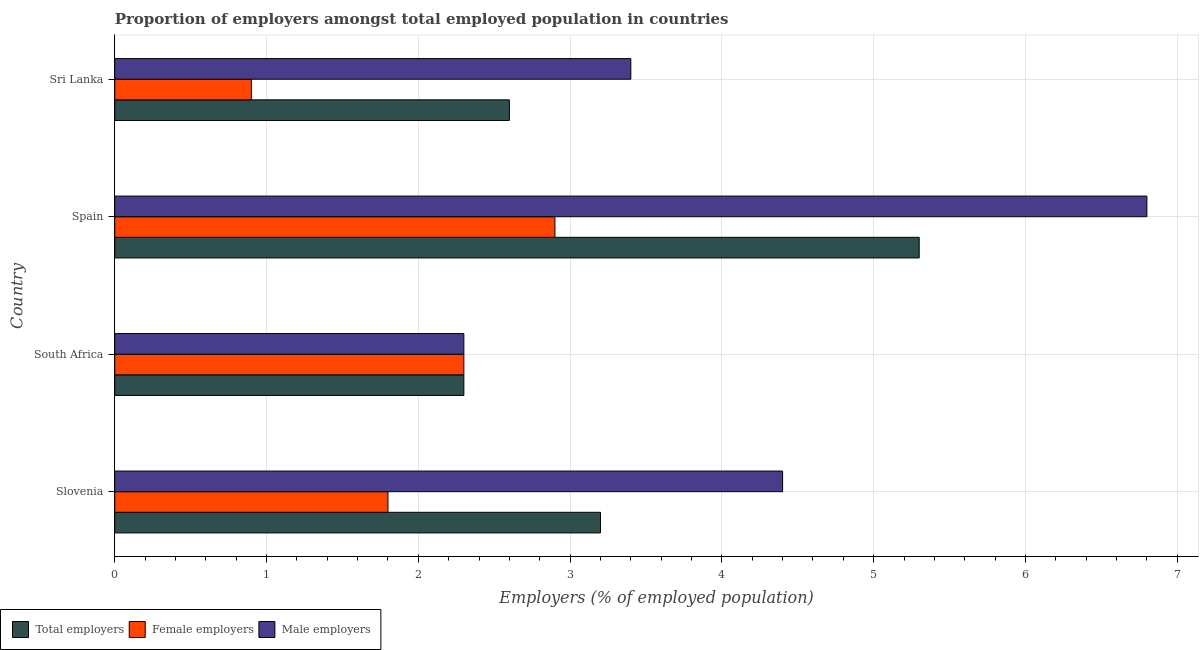How many different coloured bars are there?
Offer a very short reply. 3. Are the number of bars per tick equal to the number of legend labels?
Make the answer very short. Yes. How many bars are there on the 3rd tick from the top?
Your answer should be compact. 3. How many bars are there on the 3rd tick from the bottom?
Your response must be concise. 3. What is the label of the 4th group of bars from the top?
Make the answer very short. Slovenia. In how many cases, is the number of bars for a given country not equal to the number of legend labels?
Give a very brief answer. 0. What is the percentage of total employers in Spain?
Give a very brief answer. 5.3. Across all countries, what is the maximum percentage of male employers?
Your answer should be very brief. 6.8. Across all countries, what is the minimum percentage of male employers?
Offer a very short reply. 2.3. In which country was the percentage of male employers maximum?
Give a very brief answer. Spain. In which country was the percentage of total employers minimum?
Ensure brevity in your answer.  South Africa. What is the total percentage of female employers in the graph?
Your answer should be very brief. 7.9. What is the difference between the percentage of male employers in South Africa and the percentage of female employers in Slovenia?
Your answer should be very brief. 0.5. What is the average percentage of female employers per country?
Offer a very short reply. 1.98. What is the difference between the percentage of male employers and percentage of total employers in Sri Lanka?
Provide a succinct answer. 0.8. What is the ratio of the percentage of male employers in Slovenia to that in South Africa?
Your answer should be compact. 1.91. Is the difference between the percentage of total employers in South Africa and Spain greater than the difference between the percentage of female employers in South Africa and Spain?
Keep it short and to the point. No. What does the 2nd bar from the top in South Africa represents?
Provide a succinct answer. Female employers. What does the 1st bar from the bottom in South Africa represents?
Offer a terse response. Total employers. Are all the bars in the graph horizontal?
Offer a very short reply. Yes. Are the values on the major ticks of X-axis written in scientific E-notation?
Your answer should be compact. No. Does the graph contain any zero values?
Give a very brief answer. No. How many legend labels are there?
Your answer should be very brief. 3. What is the title of the graph?
Provide a succinct answer. Proportion of employers amongst total employed population in countries. Does "Taxes" appear as one of the legend labels in the graph?
Your response must be concise. No. What is the label or title of the X-axis?
Your answer should be compact. Employers (% of employed population). What is the label or title of the Y-axis?
Your answer should be very brief. Country. What is the Employers (% of employed population) in Total employers in Slovenia?
Offer a very short reply. 3.2. What is the Employers (% of employed population) in Female employers in Slovenia?
Offer a very short reply. 1.8. What is the Employers (% of employed population) in Male employers in Slovenia?
Offer a terse response. 4.4. What is the Employers (% of employed population) in Total employers in South Africa?
Your response must be concise. 2.3. What is the Employers (% of employed population) in Female employers in South Africa?
Ensure brevity in your answer.  2.3. What is the Employers (% of employed population) of Male employers in South Africa?
Your answer should be compact. 2.3. What is the Employers (% of employed population) in Total employers in Spain?
Provide a short and direct response. 5.3. What is the Employers (% of employed population) of Female employers in Spain?
Provide a short and direct response. 2.9. What is the Employers (% of employed population) of Male employers in Spain?
Ensure brevity in your answer.  6.8. What is the Employers (% of employed population) of Total employers in Sri Lanka?
Offer a terse response. 2.6. What is the Employers (% of employed population) in Female employers in Sri Lanka?
Give a very brief answer. 0.9. What is the Employers (% of employed population) in Male employers in Sri Lanka?
Offer a terse response. 3.4. Across all countries, what is the maximum Employers (% of employed population) in Total employers?
Offer a very short reply. 5.3. Across all countries, what is the maximum Employers (% of employed population) of Female employers?
Make the answer very short. 2.9. Across all countries, what is the maximum Employers (% of employed population) in Male employers?
Ensure brevity in your answer.  6.8. Across all countries, what is the minimum Employers (% of employed population) in Total employers?
Your answer should be compact. 2.3. Across all countries, what is the minimum Employers (% of employed population) in Female employers?
Make the answer very short. 0.9. Across all countries, what is the minimum Employers (% of employed population) in Male employers?
Offer a very short reply. 2.3. What is the total Employers (% of employed population) of Total employers in the graph?
Make the answer very short. 13.4. What is the difference between the Employers (% of employed population) in Total employers in Slovenia and that in South Africa?
Offer a very short reply. 0.9. What is the difference between the Employers (% of employed population) in Female employers in Slovenia and that in South Africa?
Keep it short and to the point. -0.5. What is the difference between the Employers (% of employed population) of Male employers in Slovenia and that in South Africa?
Make the answer very short. 2.1. What is the difference between the Employers (% of employed population) of Male employers in Slovenia and that in Spain?
Your answer should be very brief. -2.4. What is the difference between the Employers (% of employed population) of Total employers in Slovenia and that in Sri Lanka?
Give a very brief answer. 0.6. What is the difference between the Employers (% of employed population) in Female employers in Slovenia and that in Sri Lanka?
Keep it short and to the point. 0.9. What is the difference between the Employers (% of employed population) of Male employers in Slovenia and that in Sri Lanka?
Provide a succinct answer. 1. What is the difference between the Employers (% of employed population) of Total employers in South Africa and that in Spain?
Ensure brevity in your answer.  -3. What is the difference between the Employers (% of employed population) of Female employers in South Africa and that in Spain?
Give a very brief answer. -0.6. What is the difference between the Employers (% of employed population) of Total employers in Spain and that in Sri Lanka?
Your response must be concise. 2.7. What is the difference between the Employers (% of employed population) in Total employers in Slovenia and the Employers (% of employed population) in Female employers in South Africa?
Keep it short and to the point. 0.9. What is the difference between the Employers (% of employed population) of Female employers in Slovenia and the Employers (% of employed population) of Male employers in South Africa?
Provide a succinct answer. -0.5. What is the difference between the Employers (% of employed population) of Total employers in Slovenia and the Employers (% of employed population) of Female employers in Sri Lanka?
Keep it short and to the point. 2.3. What is the difference between the Employers (% of employed population) in Total employers in Slovenia and the Employers (% of employed population) in Male employers in Sri Lanka?
Provide a succinct answer. -0.2. What is the difference between the Employers (% of employed population) of Female employers in Slovenia and the Employers (% of employed population) of Male employers in Sri Lanka?
Provide a short and direct response. -1.6. What is the difference between the Employers (% of employed population) in Female employers in South Africa and the Employers (% of employed population) in Male employers in Spain?
Keep it short and to the point. -4.5. What is the difference between the Employers (% of employed population) in Total employers in South Africa and the Employers (% of employed population) in Female employers in Sri Lanka?
Your response must be concise. 1.4. What is the difference between the Employers (% of employed population) in Female employers in Spain and the Employers (% of employed population) in Male employers in Sri Lanka?
Offer a very short reply. -0.5. What is the average Employers (% of employed population) in Total employers per country?
Offer a very short reply. 3.35. What is the average Employers (% of employed population) in Female employers per country?
Make the answer very short. 1.98. What is the average Employers (% of employed population) in Male employers per country?
Make the answer very short. 4.22. What is the difference between the Employers (% of employed population) of Total employers and Employers (% of employed population) of Female employers in Slovenia?
Give a very brief answer. 1.4. What is the difference between the Employers (% of employed population) in Total employers and Employers (% of employed population) in Male employers in Slovenia?
Give a very brief answer. -1.2. What is the difference between the Employers (% of employed population) in Total employers and Employers (% of employed population) in Female employers in South Africa?
Your response must be concise. 0. What is the difference between the Employers (% of employed population) of Female employers and Employers (% of employed population) of Male employers in South Africa?
Your answer should be very brief. 0. What is the difference between the Employers (% of employed population) in Female employers and Employers (% of employed population) in Male employers in Spain?
Your answer should be compact. -3.9. What is the difference between the Employers (% of employed population) of Total employers and Employers (% of employed population) of Male employers in Sri Lanka?
Provide a succinct answer. -0.8. What is the difference between the Employers (% of employed population) in Female employers and Employers (% of employed population) in Male employers in Sri Lanka?
Your response must be concise. -2.5. What is the ratio of the Employers (% of employed population) in Total employers in Slovenia to that in South Africa?
Your answer should be compact. 1.39. What is the ratio of the Employers (% of employed population) in Female employers in Slovenia to that in South Africa?
Offer a very short reply. 0.78. What is the ratio of the Employers (% of employed population) in Male employers in Slovenia to that in South Africa?
Your answer should be compact. 1.91. What is the ratio of the Employers (% of employed population) in Total employers in Slovenia to that in Spain?
Keep it short and to the point. 0.6. What is the ratio of the Employers (% of employed population) in Female employers in Slovenia to that in Spain?
Ensure brevity in your answer.  0.62. What is the ratio of the Employers (% of employed population) in Male employers in Slovenia to that in Spain?
Give a very brief answer. 0.65. What is the ratio of the Employers (% of employed population) of Total employers in Slovenia to that in Sri Lanka?
Offer a very short reply. 1.23. What is the ratio of the Employers (% of employed population) in Male employers in Slovenia to that in Sri Lanka?
Give a very brief answer. 1.29. What is the ratio of the Employers (% of employed population) in Total employers in South Africa to that in Spain?
Provide a succinct answer. 0.43. What is the ratio of the Employers (% of employed population) in Female employers in South Africa to that in Spain?
Your response must be concise. 0.79. What is the ratio of the Employers (% of employed population) of Male employers in South Africa to that in Spain?
Ensure brevity in your answer.  0.34. What is the ratio of the Employers (% of employed population) in Total employers in South Africa to that in Sri Lanka?
Offer a terse response. 0.88. What is the ratio of the Employers (% of employed population) in Female employers in South Africa to that in Sri Lanka?
Keep it short and to the point. 2.56. What is the ratio of the Employers (% of employed population) of Male employers in South Africa to that in Sri Lanka?
Provide a succinct answer. 0.68. What is the ratio of the Employers (% of employed population) in Total employers in Spain to that in Sri Lanka?
Provide a succinct answer. 2.04. What is the ratio of the Employers (% of employed population) of Female employers in Spain to that in Sri Lanka?
Offer a terse response. 3.22. What is the ratio of the Employers (% of employed population) of Male employers in Spain to that in Sri Lanka?
Offer a terse response. 2. What is the difference between the highest and the second highest Employers (% of employed population) of Total employers?
Your answer should be very brief. 2.1. What is the difference between the highest and the second highest Employers (% of employed population) of Female employers?
Your answer should be very brief. 0.6. 